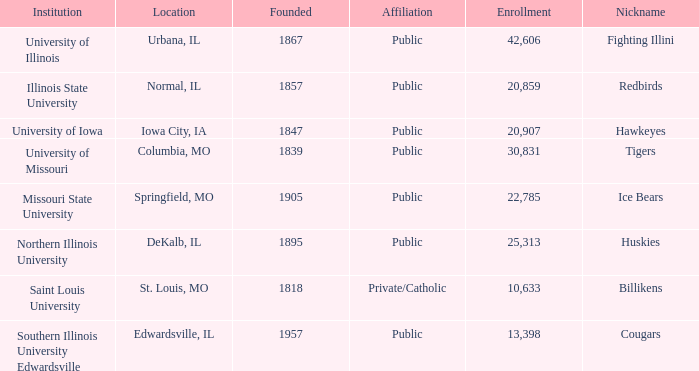Which institution is private/catholic? Saint Louis University. 